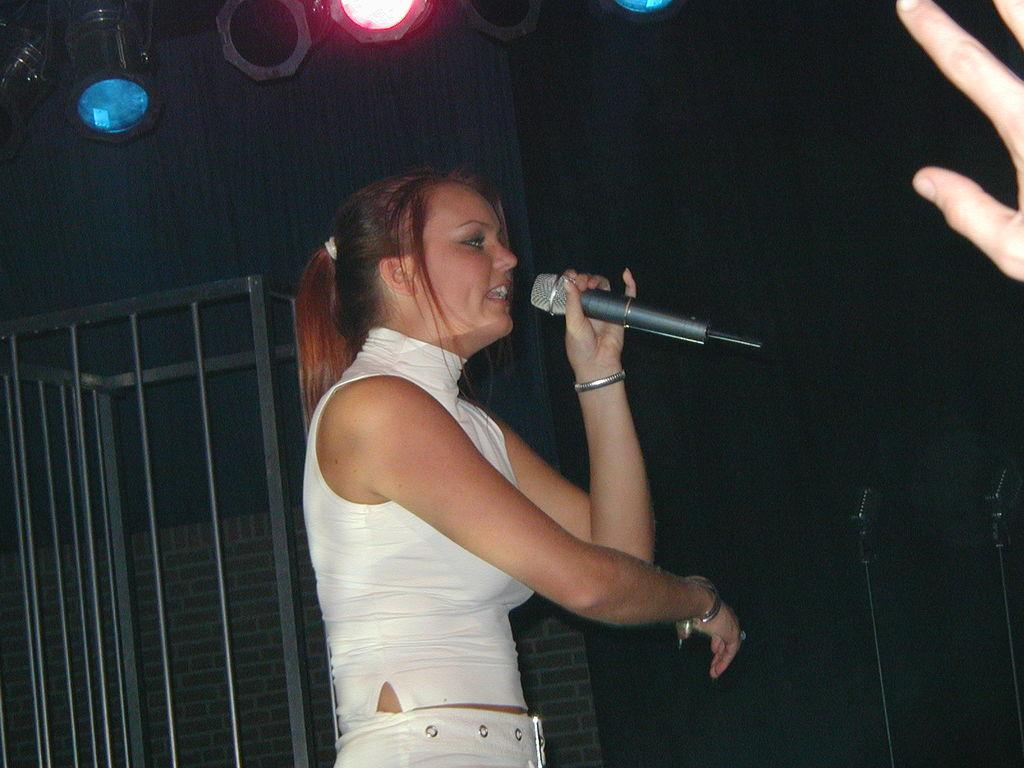Who or what is the main subject in the image? There is a person in the image. What is the person wearing? The person is wearing a white dress. What is the person holding in the image? The person is holding a mic. How many fingers are visible to the right of the person? The person has three fingers visible to the right. What can be seen in the background of the image? There are lights and a rod in the background of the image. Is the person wearing a crown in the image? No, the person is not wearing a crown in the image; they are wearing a white dress. Why is the person crying in the image? There is no indication that the person is crying in the image; they are holding a mic and have a neutral expression. 